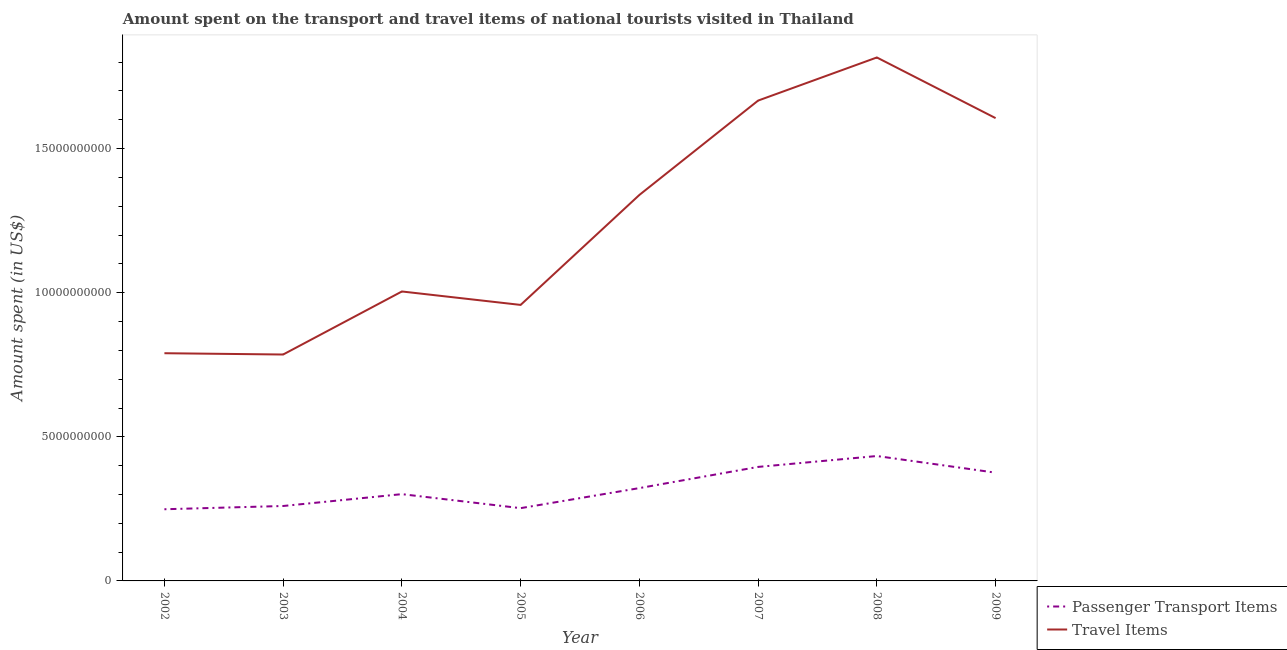How many different coloured lines are there?
Your answer should be very brief. 2. Does the line corresponding to amount spent on passenger transport items intersect with the line corresponding to amount spent in travel items?
Offer a terse response. No. What is the amount spent in travel items in 2002?
Offer a terse response. 7.90e+09. Across all years, what is the maximum amount spent in travel items?
Make the answer very short. 1.82e+1. Across all years, what is the minimum amount spent on passenger transport items?
Give a very brief answer. 2.49e+09. What is the total amount spent in travel items in the graph?
Give a very brief answer. 9.97e+1. What is the difference between the amount spent on passenger transport items in 2004 and that in 2007?
Provide a short and direct response. -9.45e+08. What is the difference between the amount spent in travel items in 2008 and the amount spent on passenger transport items in 2009?
Provide a succinct answer. 1.44e+1. What is the average amount spent on passenger transport items per year?
Your response must be concise. 3.24e+09. In the year 2004, what is the difference between the amount spent in travel items and amount spent on passenger transport items?
Offer a very short reply. 7.03e+09. What is the ratio of the amount spent on passenger transport items in 2004 to that in 2006?
Your answer should be compact. 0.93. What is the difference between the highest and the second highest amount spent in travel items?
Provide a succinct answer. 1.50e+09. What is the difference between the highest and the lowest amount spent in travel items?
Your answer should be very brief. 1.03e+1. Does the amount spent in travel items monotonically increase over the years?
Offer a very short reply. No. Is the amount spent on passenger transport items strictly greater than the amount spent in travel items over the years?
Offer a terse response. No. How many lines are there?
Your response must be concise. 2. What is the difference between two consecutive major ticks on the Y-axis?
Give a very brief answer. 5.00e+09. Does the graph contain any zero values?
Offer a very short reply. No. How are the legend labels stacked?
Your response must be concise. Vertical. What is the title of the graph?
Your answer should be compact. Amount spent on the transport and travel items of national tourists visited in Thailand. What is the label or title of the Y-axis?
Offer a terse response. Amount spent (in US$). What is the Amount spent (in US$) in Passenger Transport Items in 2002?
Your response must be concise. 2.49e+09. What is the Amount spent (in US$) in Travel Items in 2002?
Provide a short and direct response. 7.90e+09. What is the Amount spent (in US$) in Passenger Transport Items in 2003?
Keep it short and to the point. 2.60e+09. What is the Amount spent (in US$) in Travel Items in 2003?
Offer a very short reply. 7.86e+09. What is the Amount spent (in US$) in Passenger Transport Items in 2004?
Offer a very short reply. 3.01e+09. What is the Amount spent (in US$) in Travel Items in 2004?
Keep it short and to the point. 1.00e+1. What is the Amount spent (in US$) of Passenger Transport Items in 2005?
Your answer should be compact. 2.52e+09. What is the Amount spent (in US$) of Travel Items in 2005?
Ensure brevity in your answer.  9.58e+09. What is the Amount spent (in US$) of Passenger Transport Items in 2006?
Provide a short and direct response. 3.22e+09. What is the Amount spent (in US$) of Travel Items in 2006?
Your response must be concise. 1.34e+1. What is the Amount spent (in US$) in Passenger Transport Items in 2007?
Provide a succinct answer. 3.96e+09. What is the Amount spent (in US$) of Travel Items in 2007?
Provide a short and direct response. 1.67e+1. What is the Amount spent (in US$) in Passenger Transport Items in 2008?
Make the answer very short. 4.33e+09. What is the Amount spent (in US$) of Travel Items in 2008?
Make the answer very short. 1.82e+1. What is the Amount spent (in US$) in Passenger Transport Items in 2009?
Give a very brief answer. 3.76e+09. What is the Amount spent (in US$) in Travel Items in 2009?
Give a very brief answer. 1.61e+1. Across all years, what is the maximum Amount spent (in US$) of Passenger Transport Items?
Your response must be concise. 4.33e+09. Across all years, what is the maximum Amount spent (in US$) of Travel Items?
Your response must be concise. 1.82e+1. Across all years, what is the minimum Amount spent (in US$) in Passenger Transport Items?
Offer a very short reply. 2.49e+09. Across all years, what is the minimum Amount spent (in US$) in Travel Items?
Your answer should be compact. 7.86e+09. What is the total Amount spent (in US$) in Passenger Transport Items in the graph?
Offer a very short reply. 2.59e+1. What is the total Amount spent (in US$) of Travel Items in the graph?
Your answer should be very brief. 9.97e+1. What is the difference between the Amount spent (in US$) in Passenger Transport Items in 2002 and that in 2003?
Your answer should be compact. -1.13e+08. What is the difference between the Amount spent (in US$) of Travel Items in 2002 and that in 2003?
Offer a terse response. 4.50e+07. What is the difference between the Amount spent (in US$) of Passenger Transport Items in 2002 and that in 2004?
Your answer should be compact. -5.24e+08. What is the difference between the Amount spent (in US$) of Travel Items in 2002 and that in 2004?
Offer a very short reply. -2.14e+09. What is the difference between the Amount spent (in US$) of Passenger Transport Items in 2002 and that in 2005?
Offer a terse response. -3.80e+07. What is the difference between the Amount spent (in US$) of Travel Items in 2002 and that in 2005?
Your response must be concise. -1.68e+09. What is the difference between the Amount spent (in US$) in Passenger Transport Items in 2002 and that in 2006?
Your response must be concise. -7.34e+08. What is the difference between the Amount spent (in US$) in Travel Items in 2002 and that in 2006?
Keep it short and to the point. -5.49e+09. What is the difference between the Amount spent (in US$) in Passenger Transport Items in 2002 and that in 2007?
Keep it short and to the point. -1.47e+09. What is the difference between the Amount spent (in US$) of Travel Items in 2002 and that in 2007?
Keep it short and to the point. -8.77e+09. What is the difference between the Amount spent (in US$) in Passenger Transport Items in 2002 and that in 2008?
Offer a terse response. -1.85e+09. What is the difference between the Amount spent (in US$) of Travel Items in 2002 and that in 2008?
Your answer should be very brief. -1.03e+1. What is the difference between the Amount spent (in US$) in Passenger Transport Items in 2002 and that in 2009?
Offer a terse response. -1.27e+09. What is the difference between the Amount spent (in US$) of Travel Items in 2002 and that in 2009?
Your response must be concise. -8.16e+09. What is the difference between the Amount spent (in US$) in Passenger Transport Items in 2003 and that in 2004?
Give a very brief answer. -4.11e+08. What is the difference between the Amount spent (in US$) in Travel Items in 2003 and that in 2004?
Your response must be concise. -2.19e+09. What is the difference between the Amount spent (in US$) of Passenger Transport Items in 2003 and that in 2005?
Ensure brevity in your answer.  7.50e+07. What is the difference between the Amount spent (in US$) of Travel Items in 2003 and that in 2005?
Provide a short and direct response. -1.72e+09. What is the difference between the Amount spent (in US$) of Passenger Transport Items in 2003 and that in 2006?
Give a very brief answer. -6.21e+08. What is the difference between the Amount spent (in US$) in Travel Items in 2003 and that in 2006?
Your answer should be very brief. -5.54e+09. What is the difference between the Amount spent (in US$) of Passenger Transport Items in 2003 and that in 2007?
Offer a very short reply. -1.36e+09. What is the difference between the Amount spent (in US$) in Travel Items in 2003 and that in 2007?
Provide a short and direct response. -8.81e+09. What is the difference between the Amount spent (in US$) of Passenger Transport Items in 2003 and that in 2008?
Provide a short and direct response. -1.73e+09. What is the difference between the Amount spent (in US$) of Travel Items in 2003 and that in 2008?
Your answer should be very brief. -1.03e+1. What is the difference between the Amount spent (in US$) of Passenger Transport Items in 2003 and that in 2009?
Keep it short and to the point. -1.16e+09. What is the difference between the Amount spent (in US$) of Travel Items in 2003 and that in 2009?
Ensure brevity in your answer.  -8.20e+09. What is the difference between the Amount spent (in US$) of Passenger Transport Items in 2004 and that in 2005?
Ensure brevity in your answer.  4.86e+08. What is the difference between the Amount spent (in US$) of Travel Items in 2004 and that in 2005?
Provide a succinct answer. 4.66e+08. What is the difference between the Amount spent (in US$) of Passenger Transport Items in 2004 and that in 2006?
Provide a short and direct response. -2.10e+08. What is the difference between the Amount spent (in US$) in Travel Items in 2004 and that in 2006?
Your answer should be very brief. -3.35e+09. What is the difference between the Amount spent (in US$) in Passenger Transport Items in 2004 and that in 2007?
Provide a short and direct response. -9.45e+08. What is the difference between the Amount spent (in US$) in Travel Items in 2004 and that in 2007?
Keep it short and to the point. -6.62e+09. What is the difference between the Amount spent (in US$) in Passenger Transport Items in 2004 and that in 2008?
Provide a short and direct response. -1.32e+09. What is the difference between the Amount spent (in US$) in Travel Items in 2004 and that in 2008?
Offer a very short reply. -8.12e+09. What is the difference between the Amount spent (in US$) of Passenger Transport Items in 2004 and that in 2009?
Give a very brief answer. -7.45e+08. What is the difference between the Amount spent (in US$) of Travel Items in 2004 and that in 2009?
Your response must be concise. -6.02e+09. What is the difference between the Amount spent (in US$) of Passenger Transport Items in 2005 and that in 2006?
Offer a very short reply. -6.96e+08. What is the difference between the Amount spent (in US$) in Travel Items in 2005 and that in 2006?
Your answer should be very brief. -3.82e+09. What is the difference between the Amount spent (in US$) of Passenger Transport Items in 2005 and that in 2007?
Offer a terse response. -1.43e+09. What is the difference between the Amount spent (in US$) of Travel Items in 2005 and that in 2007?
Make the answer very short. -7.09e+09. What is the difference between the Amount spent (in US$) of Passenger Transport Items in 2005 and that in 2008?
Give a very brief answer. -1.81e+09. What is the difference between the Amount spent (in US$) in Travel Items in 2005 and that in 2008?
Provide a succinct answer. -8.59e+09. What is the difference between the Amount spent (in US$) in Passenger Transport Items in 2005 and that in 2009?
Offer a terse response. -1.23e+09. What is the difference between the Amount spent (in US$) in Travel Items in 2005 and that in 2009?
Keep it short and to the point. -6.48e+09. What is the difference between the Amount spent (in US$) in Passenger Transport Items in 2006 and that in 2007?
Offer a terse response. -7.35e+08. What is the difference between the Amount spent (in US$) of Travel Items in 2006 and that in 2007?
Your response must be concise. -3.27e+09. What is the difference between the Amount spent (in US$) of Passenger Transport Items in 2006 and that in 2008?
Your response must be concise. -1.11e+09. What is the difference between the Amount spent (in US$) in Travel Items in 2006 and that in 2008?
Provide a succinct answer. -4.77e+09. What is the difference between the Amount spent (in US$) in Passenger Transport Items in 2006 and that in 2009?
Ensure brevity in your answer.  -5.35e+08. What is the difference between the Amount spent (in US$) of Travel Items in 2006 and that in 2009?
Make the answer very short. -2.66e+09. What is the difference between the Amount spent (in US$) in Passenger Transport Items in 2007 and that in 2008?
Offer a very short reply. -3.78e+08. What is the difference between the Amount spent (in US$) in Travel Items in 2007 and that in 2008?
Give a very brief answer. -1.50e+09. What is the difference between the Amount spent (in US$) of Passenger Transport Items in 2007 and that in 2009?
Make the answer very short. 2.00e+08. What is the difference between the Amount spent (in US$) of Travel Items in 2007 and that in 2009?
Keep it short and to the point. 6.09e+08. What is the difference between the Amount spent (in US$) of Passenger Transport Items in 2008 and that in 2009?
Provide a succinct answer. 5.78e+08. What is the difference between the Amount spent (in US$) of Travel Items in 2008 and that in 2009?
Keep it short and to the point. 2.10e+09. What is the difference between the Amount spent (in US$) of Passenger Transport Items in 2002 and the Amount spent (in US$) of Travel Items in 2003?
Provide a short and direct response. -5.37e+09. What is the difference between the Amount spent (in US$) in Passenger Transport Items in 2002 and the Amount spent (in US$) in Travel Items in 2004?
Your answer should be very brief. -7.56e+09. What is the difference between the Amount spent (in US$) of Passenger Transport Items in 2002 and the Amount spent (in US$) of Travel Items in 2005?
Offer a very short reply. -7.09e+09. What is the difference between the Amount spent (in US$) in Passenger Transport Items in 2002 and the Amount spent (in US$) in Travel Items in 2006?
Provide a succinct answer. -1.09e+1. What is the difference between the Amount spent (in US$) of Passenger Transport Items in 2002 and the Amount spent (in US$) of Travel Items in 2007?
Give a very brief answer. -1.42e+1. What is the difference between the Amount spent (in US$) in Passenger Transport Items in 2002 and the Amount spent (in US$) in Travel Items in 2008?
Provide a succinct answer. -1.57e+1. What is the difference between the Amount spent (in US$) in Passenger Transport Items in 2002 and the Amount spent (in US$) in Travel Items in 2009?
Offer a very short reply. -1.36e+1. What is the difference between the Amount spent (in US$) of Passenger Transport Items in 2003 and the Amount spent (in US$) of Travel Items in 2004?
Offer a very short reply. -7.44e+09. What is the difference between the Amount spent (in US$) of Passenger Transport Items in 2003 and the Amount spent (in US$) of Travel Items in 2005?
Your answer should be very brief. -6.98e+09. What is the difference between the Amount spent (in US$) in Passenger Transport Items in 2003 and the Amount spent (in US$) in Travel Items in 2006?
Offer a terse response. -1.08e+1. What is the difference between the Amount spent (in US$) in Passenger Transport Items in 2003 and the Amount spent (in US$) in Travel Items in 2007?
Keep it short and to the point. -1.41e+1. What is the difference between the Amount spent (in US$) in Passenger Transport Items in 2003 and the Amount spent (in US$) in Travel Items in 2008?
Your response must be concise. -1.56e+1. What is the difference between the Amount spent (in US$) of Passenger Transport Items in 2003 and the Amount spent (in US$) of Travel Items in 2009?
Your answer should be very brief. -1.35e+1. What is the difference between the Amount spent (in US$) in Passenger Transport Items in 2004 and the Amount spent (in US$) in Travel Items in 2005?
Your response must be concise. -6.57e+09. What is the difference between the Amount spent (in US$) in Passenger Transport Items in 2004 and the Amount spent (in US$) in Travel Items in 2006?
Give a very brief answer. -1.04e+1. What is the difference between the Amount spent (in US$) in Passenger Transport Items in 2004 and the Amount spent (in US$) in Travel Items in 2007?
Your answer should be very brief. -1.37e+1. What is the difference between the Amount spent (in US$) of Passenger Transport Items in 2004 and the Amount spent (in US$) of Travel Items in 2008?
Ensure brevity in your answer.  -1.52e+1. What is the difference between the Amount spent (in US$) of Passenger Transport Items in 2004 and the Amount spent (in US$) of Travel Items in 2009?
Your response must be concise. -1.30e+1. What is the difference between the Amount spent (in US$) in Passenger Transport Items in 2005 and the Amount spent (in US$) in Travel Items in 2006?
Provide a succinct answer. -1.09e+1. What is the difference between the Amount spent (in US$) of Passenger Transport Items in 2005 and the Amount spent (in US$) of Travel Items in 2007?
Offer a terse response. -1.41e+1. What is the difference between the Amount spent (in US$) of Passenger Transport Items in 2005 and the Amount spent (in US$) of Travel Items in 2008?
Keep it short and to the point. -1.56e+1. What is the difference between the Amount spent (in US$) in Passenger Transport Items in 2005 and the Amount spent (in US$) in Travel Items in 2009?
Make the answer very short. -1.35e+1. What is the difference between the Amount spent (in US$) of Passenger Transport Items in 2006 and the Amount spent (in US$) of Travel Items in 2007?
Your response must be concise. -1.34e+1. What is the difference between the Amount spent (in US$) in Passenger Transport Items in 2006 and the Amount spent (in US$) in Travel Items in 2008?
Your response must be concise. -1.49e+1. What is the difference between the Amount spent (in US$) of Passenger Transport Items in 2006 and the Amount spent (in US$) of Travel Items in 2009?
Your answer should be compact. -1.28e+1. What is the difference between the Amount spent (in US$) in Passenger Transport Items in 2007 and the Amount spent (in US$) in Travel Items in 2008?
Provide a short and direct response. -1.42e+1. What is the difference between the Amount spent (in US$) of Passenger Transport Items in 2007 and the Amount spent (in US$) of Travel Items in 2009?
Offer a very short reply. -1.21e+1. What is the difference between the Amount spent (in US$) of Passenger Transport Items in 2008 and the Amount spent (in US$) of Travel Items in 2009?
Make the answer very short. -1.17e+1. What is the average Amount spent (in US$) of Passenger Transport Items per year?
Offer a terse response. 3.24e+09. What is the average Amount spent (in US$) of Travel Items per year?
Your response must be concise. 1.25e+1. In the year 2002, what is the difference between the Amount spent (in US$) in Passenger Transport Items and Amount spent (in US$) in Travel Items?
Give a very brief answer. -5.41e+09. In the year 2003, what is the difference between the Amount spent (in US$) of Passenger Transport Items and Amount spent (in US$) of Travel Items?
Keep it short and to the point. -5.26e+09. In the year 2004, what is the difference between the Amount spent (in US$) of Passenger Transport Items and Amount spent (in US$) of Travel Items?
Offer a very short reply. -7.03e+09. In the year 2005, what is the difference between the Amount spent (in US$) of Passenger Transport Items and Amount spent (in US$) of Travel Items?
Your answer should be very brief. -7.05e+09. In the year 2006, what is the difference between the Amount spent (in US$) of Passenger Transport Items and Amount spent (in US$) of Travel Items?
Ensure brevity in your answer.  -1.02e+1. In the year 2007, what is the difference between the Amount spent (in US$) of Passenger Transport Items and Amount spent (in US$) of Travel Items?
Provide a succinct answer. -1.27e+1. In the year 2008, what is the difference between the Amount spent (in US$) of Passenger Transport Items and Amount spent (in US$) of Travel Items?
Ensure brevity in your answer.  -1.38e+1. In the year 2009, what is the difference between the Amount spent (in US$) in Passenger Transport Items and Amount spent (in US$) in Travel Items?
Offer a terse response. -1.23e+1. What is the ratio of the Amount spent (in US$) of Passenger Transport Items in 2002 to that in 2003?
Your answer should be very brief. 0.96. What is the ratio of the Amount spent (in US$) of Passenger Transport Items in 2002 to that in 2004?
Ensure brevity in your answer.  0.83. What is the ratio of the Amount spent (in US$) in Travel Items in 2002 to that in 2004?
Provide a succinct answer. 0.79. What is the ratio of the Amount spent (in US$) in Passenger Transport Items in 2002 to that in 2005?
Your answer should be compact. 0.98. What is the ratio of the Amount spent (in US$) in Travel Items in 2002 to that in 2005?
Provide a succinct answer. 0.82. What is the ratio of the Amount spent (in US$) of Passenger Transport Items in 2002 to that in 2006?
Your answer should be compact. 0.77. What is the ratio of the Amount spent (in US$) of Travel Items in 2002 to that in 2006?
Give a very brief answer. 0.59. What is the ratio of the Amount spent (in US$) of Passenger Transport Items in 2002 to that in 2007?
Make the answer very short. 0.63. What is the ratio of the Amount spent (in US$) in Travel Items in 2002 to that in 2007?
Your response must be concise. 0.47. What is the ratio of the Amount spent (in US$) of Passenger Transport Items in 2002 to that in 2008?
Your answer should be compact. 0.57. What is the ratio of the Amount spent (in US$) in Travel Items in 2002 to that in 2008?
Keep it short and to the point. 0.43. What is the ratio of the Amount spent (in US$) in Passenger Transport Items in 2002 to that in 2009?
Ensure brevity in your answer.  0.66. What is the ratio of the Amount spent (in US$) of Travel Items in 2002 to that in 2009?
Provide a short and direct response. 0.49. What is the ratio of the Amount spent (in US$) of Passenger Transport Items in 2003 to that in 2004?
Make the answer very short. 0.86. What is the ratio of the Amount spent (in US$) in Travel Items in 2003 to that in 2004?
Keep it short and to the point. 0.78. What is the ratio of the Amount spent (in US$) in Passenger Transport Items in 2003 to that in 2005?
Your answer should be compact. 1.03. What is the ratio of the Amount spent (in US$) of Travel Items in 2003 to that in 2005?
Keep it short and to the point. 0.82. What is the ratio of the Amount spent (in US$) of Passenger Transport Items in 2003 to that in 2006?
Offer a terse response. 0.81. What is the ratio of the Amount spent (in US$) of Travel Items in 2003 to that in 2006?
Your response must be concise. 0.59. What is the ratio of the Amount spent (in US$) in Passenger Transport Items in 2003 to that in 2007?
Provide a short and direct response. 0.66. What is the ratio of the Amount spent (in US$) in Travel Items in 2003 to that in 2007?
Provide a short and direct response. 0.47. What is the ratio of the Amount spent (in US$) of Passenger Transport Items in 2003 to that in 2008?
Your response must be concise. 0.6. What is the ratio of the Amount spent (in US$) of Travel Items in 2003 to that in 2008?
Keep it short and to the point. 0.43. What is the ratio of the Amount spent (in US$) in Passenger Transport Items in 2003 to that in 2009?
Your response must be concise. 0.69. What is the ratio of the Amount spent (in US$) of Travel Items in 2003 to that in 2009?
Your answer should be compact. 0.49. What is the ratio of the Amount spent (in US$) in Passenger Transport Items in 2004 to that in 2005?
Your answer should be compact. 1.19. What is the ratio of the Amount spent (in US$) in Travel Items in 2004 to that in 2005?
Give a very brief answer. 1.05. What is the ratio of the Amount spent (in US$) of Passenger Transport Items in 2004 to that in 2006?
Your answer should be compact. 0.93. What is the ratio of the Amount spent (in US$) in Travel Items in 2004 to that in 2006?
Offer a terse response. 0.75. What is the ratio of the Amount spent (in US$) in Passenger Transport Items in 2004 to that in 2007?
Keep it short and to the point. 0.76. What is the ratio of the Amount spent (in US$) of Travel Items in 2004 to that in 2007?
Offer a very short reply. 0.6. What is the ratio of the Amount spent (in US$) of Passenger Transport Items in 2004 to that in 2008?
Your answer should be very brief. 0.69. What is the ratio of the Amount spent (in US$) in Travel Items in 2004 to that in 2008?
Your answer should be compact. 0.55. What is the ratio of the Amount spent (in US$) of Passenger Transport Items in 2004 to that in 2009?
Ensure brevity in your answer.  0.8. What is the ratio of the Amount spent (in US$) in Travel Items in 2004 to that in 2009?
Give a very brief answer. 0.63. What is the ratio of the Amount spent (in US$) of Passenger Transport Items in 2005 to that in 2006?
Offer a terse response. 0.78. What is the ratio of the Amount spent (in US$) of Travel Items in 2005 to that in 2006?
Provide a succinct answer. 0.72. What is the ratio of the Amount spent (in US$) of Passenger Transport Items in 2005 to that in 2007?
Offer a terse response. 0.64. What is the ratio of the Amount spent (in US$) in Travel Items in 2005 to that in 2007?
Your answer should be very brief. 0.57. What is the ratio of the Amount spent (in US$) in Passenger Transport Items in 2005 to that in 2008?
Make the answer very short. 0.58. What is the ratio of the Amount spent (in US$) in Travel Items in 2005 to that in 2008?
Your answer should be very brief. 0.53. What is the ratio of the Amount spent (in US$) in Passenger Transport Items in 2005 to that in 2009?
Your answer should be compact. 0.67. What is the ratio of the Amount spent (in US$) of Travel Items in 2005 to that in 2009?
Provide a succinct answer. 0.6. What is the ratio of the Amount spent (in US$) in Passenger Transport Items in 2006 to that in 2007?
Ensure brevity in your answer.  0.81. What is the ratio of the Amount spent (in US$) in Travel Items in 2006 to that in 2007?
Offer a very short reply. 0.8. What is the ratio of the Amount spent (in US$) of Passenger Transport Items in 2006 to that in 2008?
Provide a short and direct response. 0.74. What is the ratio of the Amount spent (in US$) of Travel Items in 2006 to that in 2008?
Your answer should be very brief. 0.74. What is the ratio of the Amount spent (in US$) in Passenger Transport Items in 2006 to that in 2009?
Provide a succinct answer. 0.86. What is the ratio of the Amount spent (in US$) of Travel Items in 2006 to that in 2009?
Provide a succinct answer. 0.83. What is the ratio of the Amount spent (in US$) of Passenger Transport Items in 2007 to that in 2008?
Your answer should be very brief. 0.91. What is the ratio of the Amount spent (in US$) of Travel Items in 2007 to that in 2008?
Your answer should be compact. 0.92. What is the ratio of the Amount spent (in US$) in Passenger Transport Items in 2007 to that in 2009?
Provide a succinct answer. 1.05. What is the ratio of the Amount spent (in US$) of Travel Items in 2007 to that in 2009?
Your answer should be compact. 1.04. What is the ratio of the Amount spent (in US$) in Passenger Transport Items in 2008 to that in 2009?
Offer a terse response. 1.15. What is the ratio of the Amount spent (in US$) in Travel Items in 2008 to that in 2009?
Your answer should be very brief. 1.13. What is the difference between the highest and the second highest Amount spent (in US$) of Passenger Transport Items?
Give a very brief answer. 3.78e+08. What is the difference between the highest and the second highest Amount spent (in US$) of Travel Items?
Your answer should be compact. 1.50e+09. What is the difference between the highest and the lowest Amount spent (in US$) in Passenger Transport Items?
Make the answer very short. 1.85e+09. What is the difference between the highest and the lowest Amount spent (in US$) in Travel Items?
Provide a short and direct response. 1.03e+1. 